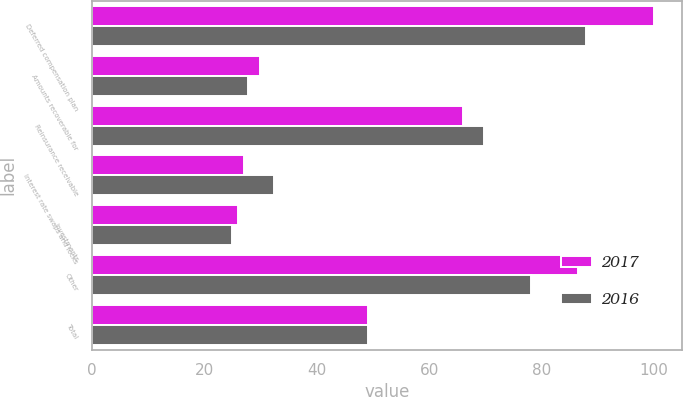Convert chart. <chart><loc_0><loc_0><loc_500><loc_500><stacked_bar_chart><ecel><fcel>Deferred compensation plan<fcel>Amounts recoverable for<fcel>Reinsurance receivable<fcel>Interest rate swaps and locks<fcel>Investments<fcel>Other<fcel>Total<nl><fcel>2017<fcel>99.9<fcel>29.9<fcel>65.9<fcel>27.1<fcel>26<fcel>86.4<fcel>49.15<nl><fcel>2016<fcel>87.9<fcel>27.7<fcel>69.7<fcel>32.4<fcel>24.8<fcel>78<fcel>49.15<nl></chart> 